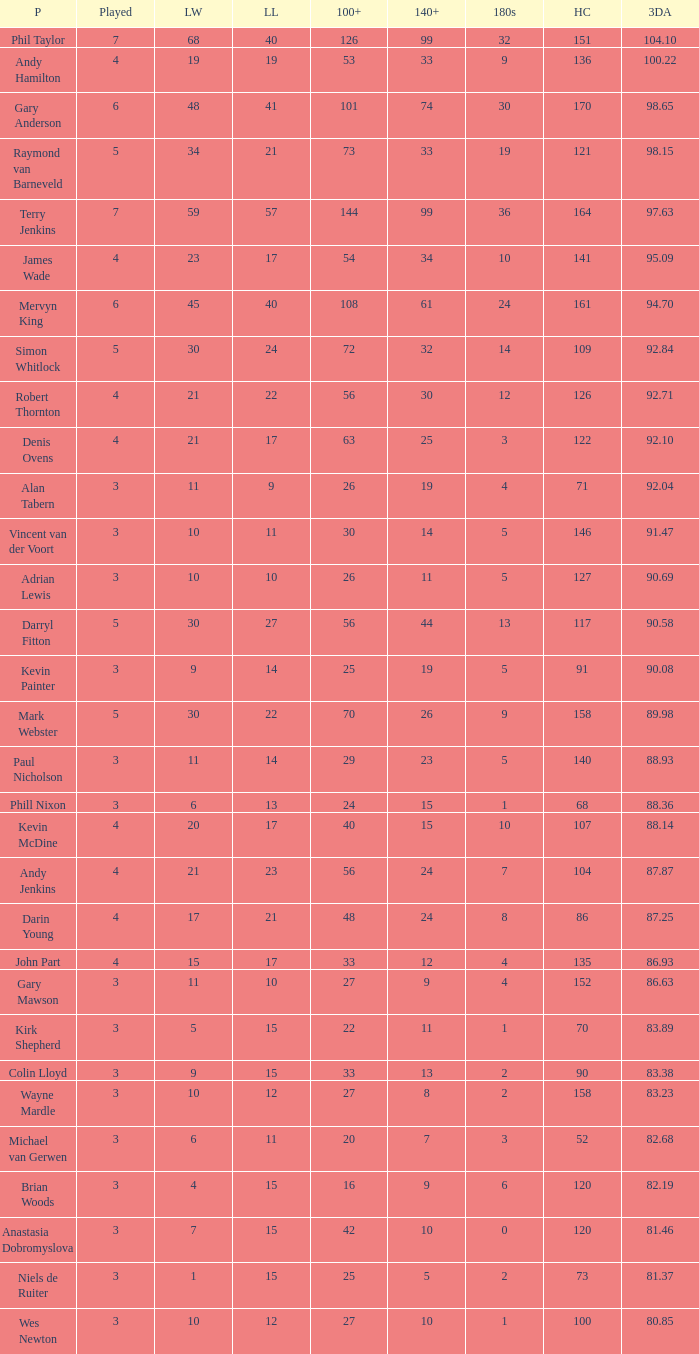What is the most legs lost of all? 57.0. 